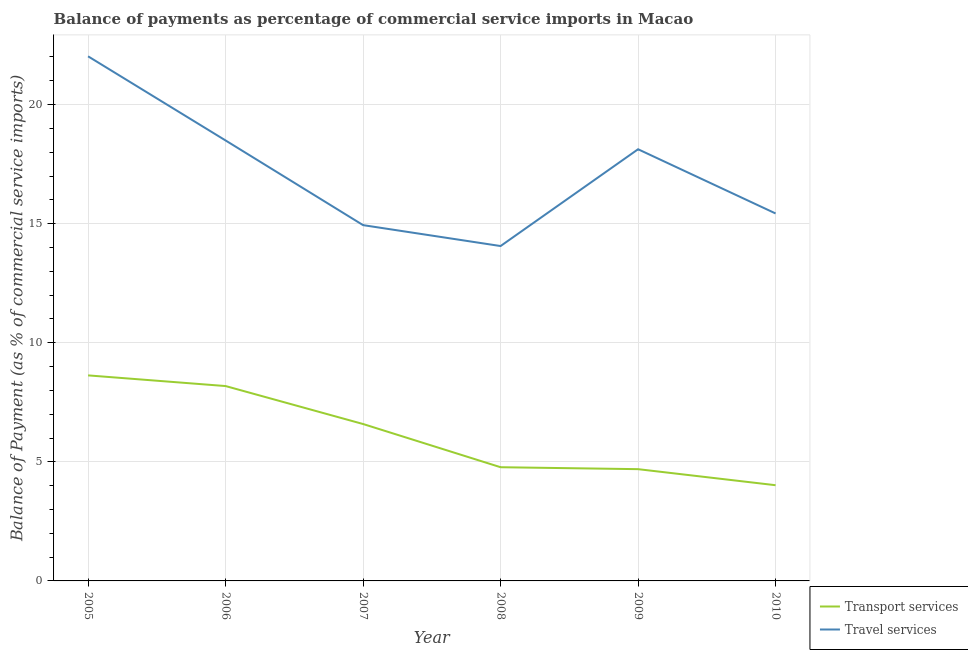Does the line corresponding to balance of payments of travel services intersect with the line corresponding to balance of payments of transport services?
Offer a terse response. No. What is the balance of payments of travel services in 2005?
Offer a terse response. 22.03. Across all years, what is the maximum balance of payments of transport services?
Give a very brief answer. 8.63. Across all years, what is the minimum balance of payments of transport services?
Provide a succinct answer. 4.02. What is the total balance of payments of transport services in the graph?
Give a very brief answer. 36.88. What is the difference between the balance of payments of travel services in 2006 and that in 2010?
Your response must be concise. 3.06. What is the difference between the balance of payments of transport services in 2008 and the balance of payments of travel services in 2005?
Provide a succinct answer. -17.25. What is the average balance of payments of travel services per year?
Provide a short and direct response. 17.18. In the year 2010, what is the difference between the balance of payments of transport services and balance of payments of travel services?
Offer a terse response. -11.41. What is the ratio of the balance of payments of travel services in 2005 to that in 2009?
Make the answer very short. 1.22. What is the difference between the highest and the second highest balance of payments of transport services?
Offer a terse response. 0.45. What is the difference between the highest and the lowest balance of payments of travel services?
Offer a very short reply. 7.97. In how many years, is the balance of payments of transport services greater than the average balance of payments of transport services taken over all years?
Make the answer very short. 3. Is the balance of payments of travel services strictly greater than the balance of payments of transport services over the years?
Provide a succinct answer. Yes. Is the balance of payments of transport services strictly less than the balance of payments of travel services over the years?
Offer a terse response. Yes. How many years are there in the graph?
Your answer should be very brief. 6. Does the graph contain any zero values?
Offer a terse response. No. Does the graph contain grids?
Keep it short and to the point. Yes. How are the legend labels stacked?
Your answer should be very brief. Vertical. What is the title of the graph?
Give a very brief answer. Balance of payments as percentage of commercial service imports in Macao. What is the label or title of the Y-axis?
Provide a succinct answer. Balance of Payment (as % of commercial service imports). What is the Balance of Payment (as % of commercial service imports) of Transport services in 2005?
Make the answer very short. 8.63. What is the Balance of Payment (as % of commercial service imports) of Travel services in 2005?
Ensure brevity in your answer.  22.03. What is the Balance of Payment (as % of commercial service imports) in Transport services in 2006?
Ensure brevity in your answer.  8.18. What is the Balance of Payment (as % of commercial service imports) of Travel services in 2006?
Your response must be concise. 18.49. What is the Balance of Payment (as % of commercial service imports) in Transport services in 2007?
Your response must be concise. 6.59. What is the Balance of Payment (as % of commercial service imports) of Travel services in 2007?
Your answer should be very brief. 14.94. What is the Balance of Payment (as % of commercial service imports) of Transport services in 2008?
Your answer should be very brief. 4.77. What is the Balance of Payment (as % of commercial service imports) in Travel services in 2008?
Keep it short and to the point. 14.06. What is the Balance of Payment (as % of commercial service imports) in Transport services in 2009?
Provide a short and direct response. 4.69. What is the Balance of Payment (as % of commercial service imports) in Travel services in 2009?
Provide a short and direct response. 18.12. What is the Balance of Payment (as % of commercial service imports) in Transport services in 2010?
Your answer should be very brief. 4.02. What is the Balance of Payment (as % of commercial service imports) in Travel services in 2010?
Offer a terse response. 15.43. Across all years, what is the maximum Balance of Payment (as % of commercial service imports) of Transport services?
Offer a very short reply. 8.63. Across all years, what is the maximum Balance of Payment (as % of commercial service imports) of Travel services?
Provide a succinct answer. 22.03. Across all years, what is the minimum Balance of Payment (as % of commercial service imports) of Transport services?
Keep it short and to the point. 4.02. Across all years, what is the minimum Balance of Payment (as % of commercial service imports) in Travel services?
Offer a terse response. 14.06. What is the total Balance of Payment (as % of commercial service imports) in Transport services in the graph?
Keep it short and to the point. 36.88. What is the total Balance of Payment (as % of commercial service imports) of Travel services in the graph?
Ensure brevity in your answer.  103.07. What is the difference between the Balance of Payment (as % of commercial service imports) of Transport services in 2005 and that in 2006?
Offer a terse response. 0.45. What is the difference between the Balance of Payment (as % of commercial service imports) in Travel services in 2005 and that in 2006?
Your answer should be very brief. 3.53. What is the difference between the Balance of Payment (as % of commercial service imports) in Transport services in 2005 and that in 2007?
Offer a very short reply. 2.04. What is the difference between the Balance of Payment (as % of commercial service imports) of Travel services in 2005 and that in 2007?
Your answer should be very brief. 7.09. What is the difference between the Balance of Payment (as % of commercial service imports) of Transport services in 2005 and that in 2008?
Make the answer very short. 3.86. What is the difference between the Balance of Payment (as % of commercial service imports) of Travel services in 2005 and that in 2008?
Your answer should be compact. 7.97. What is the difference between the Balance of Payment (as % of commercial service imports) of Transport services in 2005 and that in 2009?
Provide a succinct answer. 3.94. What is the difference between the Balance of Payment (as % of commercial service imports) in Travel services in 2005 and that in 2009?
Give a very brief answer. 3.9. What is the difference between the Balance of Payment (as % of commercial service imports) in Transport services in 2005 and that in 2010?
Provide a short and direct response. 4.61. What is the difference between the Balance of Payment (as % of commercial service imports) of Travel services in 2005 and that in 2010?
Offer a terse response. 6.6. What is the difference between the Balance of Payment (as % of commercial service imports) of Transport services in 2006 and that in 2007?
Your response must be concise. 1.59. What is the difference between the Balance of Payment (as % of commercial service imports) of Travel services in 2006 and that in 2007?
Offer a terse response. 3.55. What is the difference between the Balance of Payment (as % of commercial service imports) in Transport services in 2006 and that in 2008?
Your answer should be very brief. 3.41. What is the difference between the Balance of Payment (as % of commercial service imports) in Travel services in 2006 and that in 2008?
Make the answer very short. 4.43. What is the difference between the Balance of Payment (as % of commercial service imports) in Transport services in 2006 and that in 2009?
Offer a terse response. 3.49. What is the difference between the Balance of Payment (as % of commercial service imports) in Travel services in 2006 and that in 2009?
Offer a very short reply. 0.37. What is the difference between the Balance of Payment (as % of commercial service imports) of Transport services in 2006 and that in 2010?
Offer a terse response. 4.16. What is the difference between the Balance of Payment (as % of commercial service imports) of Travel services in 2006 and that in 2010?
Offer a very short reply. 3.06. What is the difference between the Balance of Payment (as % of commercial service imports) in Transport services in 2007 and that in 2008?
Give a very brief answer. 1.81. What is the difference between the Balance of Payment (as % of commercial service imports) of Travel services in 2007 and that in 2008?
Give a very brief answer. 0.88. What is the difference between the Balance of Payment (as % of commercial service imports) in Transport services in 2007 and that in 2009?
Give a very brief answer. 1.9. What is the difference between the Balance of Payment (as % of commercial service imports) of Travel services in 2007 and that in 2009?
Your answer should be very brief. -3.19. What is the difference between the Balance of Payment (as % of commercial service imports) of Transport services in 2007 and that in 2010?
Keep it short and to the point. 2.57. What is the difference between the Balance of Payment (as % of commercial service imports) of Travel services in 2007 and that in 2010?
Provide a short and direct response. -0.49. What is the difference between the Balance of Payment (as % of commercial service imports) of Transport services in 2008 and that in 2009?
Your response must be concise. 0.08. What is the difference between the Balance of Payment (as % of commercial service imports) in Travel services in 2008 and that in 2009?
Ensure brevity in your answer.  -4.06. What is the difference between the Balance of Payment (as % of commercial service imports) in Transport services in 2008 and that in 2010?
Provide a short and direct response. 0.76. What is the difference between the Balance of Payment (as % of commercial service imports) in Travel services in 2008 and that in 2010?
Your answer should be compact. -1.37. What is the difference between the Balance of Payment (as % of commercial service imports) of Transport services in 2009 and that in 2010?
Keep it short and to the point. 0.67. What is the difference between the Balance of Payment (as % of commercial service imports) in Travel services in 2009 and that in 2010?
Offer a very short reply. 2.7. What is the difference between the Balance of Payment (as % of commercial service imports) in Transport services in 2005 and the Balance of Payment (as % of commercial service imports) in Travel services in 2006?
Your answer should be compact. -9.86. What is the difference between the Balance of Payment (as % of commercial service imports) in Transport services in 2005 and the Balance of Payment (as % of commercial service imports) in Travel services in 2007?
Your answer should be very brief. -6.31. What is the difference between the Balance of Payment (as % of commercial service imports) of Transport services in 2005 and the Balance of Payment (as % of commercial service imports) of Travel services in 2008?
Offer a terse response. -5.43. What is the difference between the Balance of Payment (as % of commercial service imports) of Transport services in 2005 and the Balance of Payment (as % of commercial service imports) of Travel services in 2009?
Offer a terse response. -9.49. What is the difference between the Balance of Payment (as % of commercial service imports) of Transport services in 2005 and the Balance of Payment (as % of commercial service imports) of Travel services in 2010?
Your response must be concise. -6.8. What is the difference between the Balance of Payment (as % of commercial service imports) of Transport services in 2006 and the Balance of Payment (as % of commercial service imports) of Travel services in 2007?
Provide a succinct answer. -6.76. What is the difference between the Balance of Payment (as % of commercial service imports) in Transport services in 2006 and the Balance of Payment (as % of commercial service imports) in Travel services in 2008?
Your answer should be very brief. -5.88. What is the difference between the Balance of Payment (as % of commercial service imports) of Transport services in 2006 and the Balance of Payment (as % of commercial service imports) of Travel services in 2009?
Your answer should be compact. -9.94. What is the difference between the Balance of Payment (as % of commercial service imports) of Transport services in 2006 and the Balance of Payment (as % of commercial service imports) of Travel services in 2010?
Offer a very short reply. -7.25. What is the difference between the Balance of Payment (as % of commercial service imports) in Transport services in 2007 and the Balance of Payment (as % of commercial service imports) in Travel services in 2008?
Provide a short and direct response. -7.47. What is the difference between the Balance of Payment (as % of commercial service imports) of Transport services in 2007 and the Balance of Payment (as % of commercial service imports) of Travel services in 2009?
Provide a succinct answer. -11.54. What is the difference between the Balance of Payment (as % of commercial service imports) of Transport services in 2007 and the Balance of Payment (as % of commercial service imports) of Travel services in 2010?
Provide a short and direct response. -8.84. What is the difference between the Balance of Payment (as % of commercial service imports) in Transport services in 2008 and the Balance of Payment (as % of commercial service imports) in Travel services in 2009?
Keep it short and to the point. -13.35. What is the difference between the Balance of Payment (as % of commercial service imports) in Transport services in 2008 and the Balance of Payment (as % of commercial service imports) in Travel services in 2010?
Your response must be concise. -10.65. What is the difference between the Balance of Payment (as % of commercial service imports) in Transport services in 2009 and the Balance of Payment (as % of commercial service imports) in Travel services in 2010?
Your answer should be very brief. -10.74. What is the average Balance of Payment (as % of commercial service imports) of Transport services per year?
Give a very brief answer. 6.15. What is the average Balance of Payment (as % of commercial service imports) of Travel services per year?
Ensure brevity in your answer.  17.18. In the year 2005, what is the difference between the Balance of Payment (as % of commercial service imports) in Transport services and Balance of Payment (as % of commercial service imports) in Travel services?
Your answer should be compact. -13.4. In the year 2006, what is the difference between the Balance of Payment (as % of commercial service imports) of Transport services and Balance of Payment (as % of commercial service imports) of Travel services?
Offer a very short reply. -10.31. In the year 2007, what is the difference between the Balance of Payment (as % of commercial service imports) of Transport services and Balance of Payment (as % of commercial service imports) of Travel services?
Offer a very short reply. -8.35. In the year 2008, what is the difference between the Balance of Payment (as % of commercial service imports) in Transport services and Balance of Payment (as % of commercial service imports) in Travel services?
Give a very brief answer. -9.29. In the year 2009, what is the difference between the Balance of Payment (as % of commercial service imports) in Transport services and Balance of Payment (as % of commercial service imports) in Travel services?
Your response must be concise. -13.43. In the year 2010, what is the difference between the Balance of Payment (as % of commercial service imports) in Transport services and Balance of Payment (as % of commercial service imports) in Travel services?
Your answer should be compact. -11.41. What is the ratio of the Balance of Payment (as % of commercial service imports) in Transport services in 2005 to that in 2006?
Offer a terse response. 1.05. What is the ratio of the Balance of Payment (as % of commercial service imports) of Travel services in 2005 to that in 2006?
Your response must be concise. 1.19. What is the ratio of the Balance of Payment (as % of commercial service imports) of Transport services in 2005 to that in 2007?
Keep it short and to the point. 1.31. What is the ratio of the Balance of Payment (as % of commercial service imports) of Travel services in 2005 to that in 2007?
Provide a succinct answer. 1.47. What is the ratio of the Balance of Payment (as % of commercial service imports) of Transport services in 2005 to that in 2008?
Ensure brevity in your answer.  1.81. What is the ratio of the Balance of Payment (as % of commercial service imports) of Travel services in 2005 to that in 2008?
Provide a short and direct response. 1.57. What is the ratio of the Balance of Payment (as % of commercial service imports) in Transport services in 2005 to that in 2009?
Offer a terse response. 1.84. What is the ratio of the Balance of Payment (as % of commercial service imports) in Travel services in 2005 to that in 2009?
Provide a short and direct response. 1.22. What is the ratio of the Balance of Payment (as % of commercial service imports) in Transport services in 2005 to that in 2010?
Your response must be concise. 2.15. What is the ratio of the Balance of Payment (as % of commercial service imports) of Travel services in 2005 to that in 2010?
Ensure brevity in your answer.  1.43. What is the ratio of the Balance of Payment (as % of commercial service imports) of Transport services in 2006 to that in 2007?
Keep it short and to the point. 1.24. What is the ratio of the Balance of Payment (as % of commercial service imports) of Travel services in 2006 to that in 2007?
Give a very brief answer. 1.24. What is the ratio of the Balance of Payment (as % of commercial service imports) in Transport services in 2006 to that in 2008?
Ensure brevity in your answer.  1.71. What is the ratio of the Balance of Payment (as % of commercial service imports) in Travel services in 2006 to that in 2008?
Provide a succinct answer. 1.32. What is the ratio of the Balance of Payment (as % of commercial service imports) of Transport services in 2006 to that in 2009?
Keep it short and to the point. 1.74. What is the ratio of the Balance of Payment (as % of commercial service imports) of Travel services in 2006 to that in 2009?
Provide a short and direct response. 1.02. What is the ratio of the Balance of Payment (as % of commercial service imports) in Transport services in 2006 to that in 2010?
Keep it short and to the point. 2.04. What is the ratio of the Balance of Payment (as % of commercial service imports) of Travel services in 2006 to that in 2010?
Your answer should be compact. 1.2. What is the ratio of the Balance of Payment (as % of commercial service imports) of Transport services in 2007 to that in 2008?
Your answer should be compact. 1.38. What is the ratio of the Balance of Payment (as % of commercial service imports) of Travel services in 2007 to that in 2008?
Ensure brevity in your answer.  1.06. What is the ratio of the Balance of Payment (as % of commercial service imports) in Transport services in 2007 to that in 2009?
Ensure brevity in your answer.  1.4. What is the ratio of the Balance of Payment (as % of commercial service imports) in Travel services in 2007 to that in 2009?
Your answer should be very brief. 0.82. What is the ratio of the Balance of Payment (as % of commercial service imports) in Transport services in 2007 to that in 2010?
Provide a succinct answer. 1.64. What is the ratio of the Balance of Payment (as % of commercial service imports) of Travel services in 2007 to that in 2010?
Your answer should be compact. 0.97. What is the ratio of the Balance of Payment (as % of commercial service imports) in Transport services in 2008 to that in 2009?
Offer a very short reply. 1.02. What is the ratio of the Balance of Payment (as % of commercial service imports) in Travel services in 2008 to that in 2009?
Make the answer very short. 0.78. What is the ratio of the Balance of Payment (as % of commercial service imports) of Transport services in 2008 to that in 2010?
Your answer should be compact. 1.19. What is the ratio of the Balance of Payment (as % of commercial service imports) of Travel services in 2008 to that in 2010?
Keep it short and to the point. 0.91. What is the ratio of the Balance of Payment (as % of commercial service imports) of Transport services in 2009 to that in 2010?
Ensure brevity in your answer.  1.17. What is the ratio of the Balance of Payment (as % of commercial service imports) of Travel services in 2009 to that in 2010?
Give a very brief answer. 1.17. What is the difference between the highest and the second highest Balance of Payment (as % of commercial service imports) of Transport services?
Your answer should be compact. 0.45. What is the difference between the highest and the second highest Balance of Payment (as % of commercial service imports) of Travel services?
Offer a terse response. 3.53. What is the difference between the highest and the lowest Balance of Payment (as % of commercial service imports) of Transport services?
Your answer should be very brief. 4.61. What is the difference between the highest and the lowest Balance of Payment (as % of commercial service imports) in Travel services?
Offer a very short reply. 7.97. 